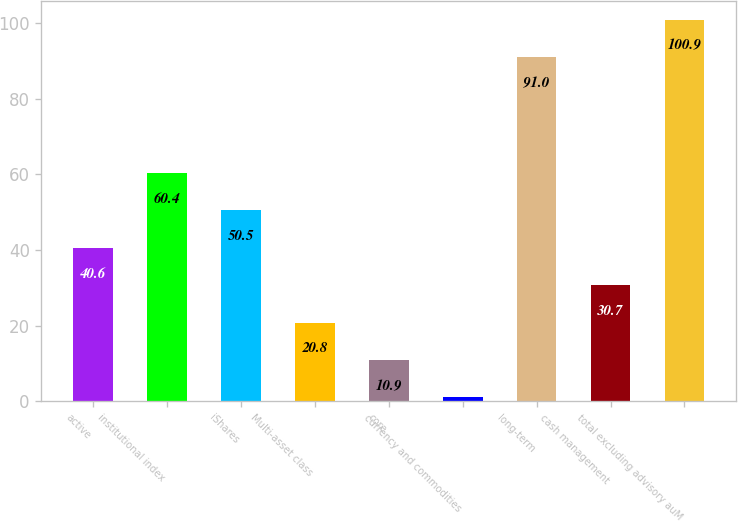Convert chart to OTSL. <chart><loc_0><loc_0><loc_500><loc_500><bar_chart><fcel>active<fcel>institutional index<fcel>iShares<fcel>Multi-asset class<fcel>core<fcel>currency and commodities<fcel>long-term<fcel>cash management<fcel>total excluding advisory auM<nl><fcel>40.6<fcel>60.4<fcel>50.5<fcel>20.8<fcel>10.9<fcel>1<fcel>91<fcel>30.7<fcel>100.9<nl></chart> 